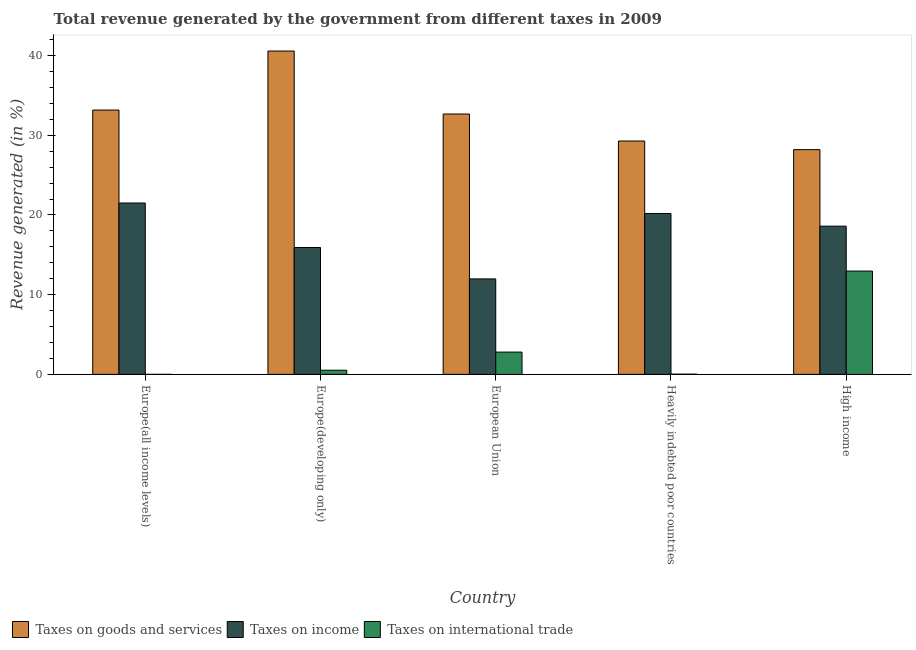Are the number of bars on each tick of the X-axis equal?
Offer a terse response. Yes. What is the percentage of revenue generated by taxes on income in High income?
Your answer should be compact. 18.6. Across all countries, what is the maximum percentage of revenue generated by taxes on goods and services?
Provide a short and direct response. 40.57. Across all countries, what is the minimum percentage of revenue generated by tax on international trade?
Keep it short and to the point. 0. In which country was the percentage of revenue generated by taxes on income maximum?
Offer a very short reply. Europe(all income levels). In which country was the percentage of revenue generated by taxes on goods and services minimum?
Make the answer very short. High income. What is the total percentage of revenue generated by tax on international trade in the graph?
Your answer should be very brief. 16.31. What is the difference between the percentage of revenue generated by taxes on goods and services in Europe(all income levels) and that in Europe(developing only)?
Ensure brevity in your answer.  -7.41. What is the difference between the percentage of revenue generated by tax on international trade in High income and the percentage of revenue generated by taxes on goods and services in Europe(developing only)?
Your answer should be very brief. -27.61. What is the average percentage of revenue generated by taxes on income per country?
Ensure brevity in your answer.  17.64. What is the difference between the percentage of revenue generated by tax on international trade and percentage of revenue generated by taxes on income in Europe(developing only)?
Your answer should be very brief. -15.4. In how many countries, is the percentage of revenue generated by tax on international trade greater than 22 %?
Give a very brief answer. 0. What is the ratio of the percentage of revenue generated by taxes on income in Europe(all income levels) to that in European Union?
Keep it short and to the point. 1.79. Is the percentage of revenue generated by tax on international trade in Europe(developing only) less than that in High income?
Your answer should be very brief. Yes. Is the difference between the percentage of revenue generated by taxes on goods and services in Europe(all income levels) and High income greater than the difference between the percentage of revenue generated by tax on international trade in Europe(all income levels) and High income?
Your answer should be compact. Yes. What is the difference between the highest and the second highest percentage of revenue generated by taxes on goods and services?
Your answer should be very brief. 7.41. What is the difference between the highest and the lowest percentage of revenue generated by taxes on goods and services?
Provide a short and direct response. 12.37. Is the sum of the percentage of revenue generated by tax on international trade in Europe(developing only) and High income greater than the maximum percentage of revenue generated by taxes on income across all countries?
Give a very brief answer. No. What does the 3rd bar from the left in Europe(all income levels) represents?
Offer a terse response. Taxes on international trade. What does the 3rd bar from the right in Europe(all income levels) represents?
Offer a terse response. Taxes on goods and services. How many bars are there?
Provide a succinct answer. 15. Are all the bars in the graph horizontal?
Keep it short and to the point. No. Does the graph contain any zero values?
Provide a short and direct response. No. Does the graph contain grids?
Keep it short and to the point. No. How are the legend labels stacked?
Make the answer very short. Horizontal. What is the title of the graph?
Your answer should be very brief. Total revenue generated by the government from different taxes in 2009. Does "Social Protection and Labor" appear as one of the legend labels in the graph?
Your response must be concise. No. What is the label or title of the X-axis?
Give a very brief answer. Country. What is the label or title of the Y-axis?
Keep it short and to the point. Revenue generated (in %). What is the Revenue generated (in %) in Taxes on goods and services in Europe(all income levels)?
Your response must be concise. 33.17. What is the Revenue generated (in %) in Taxes on income in Europe(all income levels)?
Make the answer very short. 21.5. What is the Revenue generated (in %) of Taxes on international trade in Europe(all income levels)?
Your answer should be very brief. 0. What is the Revenue generated (in %) in Taxes on goods and services in Europe(developing only)?
Provide a succinct answer. 40.57. What is the Revenue generated (in %) of Taxes on income in Europe(developing only)?
Give a very brief answer. 15.92. What is the Revenue generated (in %) in Taxes on international trade in Europe(developing only)?
Give a very brief answer. 0.52. What is the Revenue generated (in %) of Taxes on goods and services in European Union?
Give a very brief answer. 32.67. What is the Revenue generated (in %) of Taxes on income in European Union?
Give a very brief answer. 11.98. What is the Revenue generated (in %) in Taxes on international trade in European Union?
Your answer should be compact. 2.8. What is the Revenue generated (in %) in Taxes on goods and services in Heavily indebted poor countries?
Ensure brevity in your answer.  29.28. What is the Revenue generated (in %) in Taxes on income in Heavily indebted poor countries?
Your answer should be very brief. 20.19. What is the Revenue generated (in %) of Taxes on international trade in Heavily indebted poor countries?
Your answer should be very brief. 0.02. What is the Revenue generated (in %) in Taxes on goods and services in High income?
Your response must be concise. 28.2. What is the Revenue generated (in %) of Taxes on income in High income?
Offer a very short reply. 18.6. What is the Revenue generated (in %) in Taxes on international trade in High income?
Provide a succinct answer. 12.96. Across all countries, what is the maximum Revenue generated (in %) in Taxes on goods and services?
Your answer should be compact. 40.57. Across all countries, what is the maximum Revenue generated (in %) in Taxes on income?
Your response must be concise. 21.5. Across all countries, what is the maximum Revenue generated (in %) in Taxes on international trade?
Give a very brief answer. 12.96. Across all countries, what is the minimum Revenue generated (in %) in Taxes on goods and services?
Offer a terse response. 28.2. Across all countries, what is the minimum Revenue generated (in %) of Taxes on income?
Your answer should be compact. 11.98. Across all countries, what is the minimum Revenue generated (in %) in Taxes on international trade?
Provide a succinct answer. 0. What is the total Revenue generated (in %) in Taxes on goods and services in the graph?
Provide a short and direct response. 163.89. What is the total Revenue generated (in %) of Taxes on income in the graph?
Your answer should be very brief. 88.19. What is the total Revenue generated (in %) of Taxes on international trade in the graph?
Provide a short and direct response. 16.31. What is the difference between the Revenue generated (in %) of Taxes on goods and services in Europe(all income levels) and that in Europe(developing only)?
Offer a terse response. -7.41. What is the difference between the Revenue generated (in %) in Taxes on income in Europe(all income levels) and that in Europe(developing only)?
Provide a succinct answer. 5.58. What is the difference between the Revenue generated (in %) in Taxes on international trade in Europe(all income levels) and that in Europe(developing only)?
Offer a very short reply. -0.52. What is the difference between the Revenue generated (in %) of Taxes on goods and services in Europe(all income levels) and that in European Union?
Give a very brief answer. 0.5. What is the difference between the Revenue generated (in %) in Taxes on income in Europe(all income levels) and that in European Union?
Your response must be concise. 9.52. What is the difference between the Revenue generated (in %) of Taxes on international trade in Europe(all income levels) and that in European Union?
Give a very brief answer. -2.79. What is the difference between the Revenue generated (in %) of Taxes on goods and services in Europe(all income levels) and that in Heavily indebted poor countries?
Offer a very short reply. 3.89. What is the difference between the Revenue generated (in %) in Taxes on income in Europe(all income levels) and that in Heavily indebted poor countries?
Ensure brevity in your answer.  1.31. What is the difference between the Revenue generated (in %) in Taxes on international trade in Europe(all income levels) and that in Heavily indebted poor countries?
Provide a short and direct response. -0.02. What is the difference between the Revenue generated (in %) of Taxes on goods and services in Europe(all income levels) and that in High income?
Offer a terse response. 4.97. What is the difference between the Revenue generated (in %) of Taxes on income in Europe(all income levels) and that in High income?
Offer a terse response. 2.9. What is the difference between the Revenue generated (in %) of Taxes on international trade in Europe(all income levels) and that in High income?
Offer a terse response. -12.96. What is the difference between the Revenue generated (in %) in Taxes on goods and services in Europe(developing only) and that in European Union?
Give a very brief answer. 7.9. What is the difference between the Revenue generated (in %) of Taxes on income in Europe(developing only) and that in European Union?
Your answer should be compact. 3.94. What is the difference between the Revenue generated (in %) of Taxes on international trade in Europe(developing only) and that in European Union?
Your response must be concise. -2.27. What is the difference between the Revenue generated (in %) in Taxes on goods and services in Europe(developing only) and that in Heavily indebted poor countries?
Your response must be concise. 11.29. What is the difference between the Revenue generated (in %) of Taxes on income in Europe(developing only) and that in Heavily indebted poor countries?
Your answer should be compact. -4.27. What is the difference between the Revenue generated (in %) of Taxes on international trade in Europe(developing only) and that in Heavily indebted poor countries?
Make the answer very short. 0.5. What is the difference between the Revenue generated (in %) in Taxes on goods and services in Europe(developing only) and that in High income?
Offer a terse response. 12.37. What is the difference between the Revenue generated (in %) of Taxes on income in Europe(developing only) and that in High income?
Provide a succinct answer. -2.68. What is the difference between the Revenue generated (in %) of Taxes on international trade in Europe(developing only) and that in High income?
Your answer should be compact. -12.44. What is the difference between the Revenue generated (in %) of Taxes on goods and services in European Union and that in Heavily indebted poor countries?
Your answer should be very brief. 3.39. What is the difference between the Revenue generated (in %) in Taxes on income in European Union and that in Heavily indebted poor countries?
Your response must be concise. -8.21. What is the difference between the Revenue generated (in %) of Taxes on international trade in European Union and that in Heavily indebted poor countries?
Give a very brief answer. 2.77. What is the difference between the Revenue generated (in %) of Taxes on goods and services in European Union and that in High income?
Make the answer very short. 4.47. What is the difference between the Revenue generated (in %) of Taxes on income in European Union and that in High income?
Your response must be concise. -6.62. What is the difference between the Revenue generated (in %) in Taxes on international trade in European Union and that in High income?
Offer a terse response. -10.17. What is the difference between the Revenue generated (in %) of Taxes on goods and services in Heavily indebted poor countries and that in High income?
Make the answer very short. 1.08. What is the difference between the Revenue generated (in %) of Taxes on income in Heavily indebted poor countries and that in High income?
Ensure brevity in your answer.  1.59. What is the difference between the Revenue generated (in %) of Taxes on international trade in Heavily indebted poor countries and that in High income?
Provide a short and direct response. -12.94. What is the difference between the Revenue generated (in %) in Taxes on goods and services in Europe(all income levels) and the Revenue generated (in %) in Taxes on income in Europe(developing only)?
Make the answer very short. 17.25. What is the difference between the Revenue generated (in %) in Taxes on goods and services in Europe(all income levels) and the Revenue generated (in %) in Taxes on international trade in Europe(developing only)?
Offer a very short reply. 32.64. What is the difference between the Revenue generated (in %) in Taxes on income in Europe(all income levels) and the Revenue generated (in %) in Taxes on international trade in Europe(developing only)?
Keep it short and to the point. 20.98. What is the difference between the Revenue generated (in %) of Taxes on goods and services in Europe(all income levels) and the Revenue generated (in %) of Taxes on income in European Union?
Your answer should be compact. 21.19. What is the difference between the Revenue generated (in %) of Taxes on goods and services in Europe(all income levels) and the Revenue generated (in %) of Taxes on international trade in European Union?
Provide a succinct answer. 30.37. What is the difference between the Revenue generated (in %) in Taxes on income in Europe(all income levels) and the Revenue generated (in %) in Taxes on international trade in European Union?
Make the answer very short. 18.71. What is the difference between the Revenue generated (in %) in Taxes on goods and services in Europe(all income levels) and the Revenue generated (in %) in Taxes on income in Heavily indebted poor countries?
Offer a terse response. 12.98. What is the difference between the Revenue generated (in %) in Taxes on goods and services in Europe(all income levels) and the Revenue generated (in %) in Taxes on international trade in Heavily indebted poor countries?
Offer a very short reply. 33.14. What is the difference between the Revenue generated (in %) in Taxes on income in Europe(all income levels) and the Revenue generated (in %) in Taxes on international trade in Heavily indebted poor countries?
Provide a short and direct response. 21.48. What is the difference between the Revenue generated (in %) in Taxes on goods and services in Europe(all income levels) and the Revenue generated (in %) in Taxes on income in High income?
Provide a succinct answer. 14.57. What is the difference between the Revenue generated (in %) of Taxes on goods and services in Europe(all income levels) and the Revenue generated (in %) of Taxes on international trade in High income?
Provide a short and direct response. 20.2. What is the difference between the Revenue generated (in %) of Taxes on income in Europe(all income levels) and the Revenue generated (in %) of Taxes on international trade in High income?
Offer a very short reply. 8.54. What is the difference between the Revenue generated (in %) of Taxes on goods and services in Europe(developing only) and the Revenue generated (in %) of Taxes on income in European Union?
Your response must be concise. 28.59. What is the difference between the Revenue generated (in %) in Taxes on goods and services in Europe(developing only) and the Revenue generated (in %) in Taxes on international trade in European Union?
Provide a succinct answer. 37.78. What is the difference between the Revenue generated (in %) of Taxes on income in Europe(developing only) and the Revenue generated (in %) of Taxes on international trade in European Union?
Keep it short and to the point. 13.12. What is the difference between the Revenue generated (in %) in Taxes on goods and services in Europe(developing only) and the Revenue generated (in %) in Taxes on income in Heavily indebted poor countries?
Your answer should be very brief. 20.38. What is the difference between the Revenue generated (in %) in Taxes on goods and services in Europe(developing only) and the Revenue generated (in %) in Taxes on international trade in Heavily indebted poor countries?
Offer a very short reply. 40.55. What is the difference between the Revenue generated (in %) of Taxes on income in Europe(developing only) and the Revenue generated (in %) of Taxes on international trade in Heavily indebted poor countries?
Offer a very short reply. 15.9. What is the difference between the Revenue generated (in %) of Taxes on goods and services in Europe(developing only) and the Revenue generated (in %) of Taxes on income in High income?
Your response must be concise. 21.97. What is the difference between the Revenue generated (in %) in Taxes on goods and services in Europe(developing only) and the Revenue generated (in %) in Taxes on international trade in High income?
Offer a very short reply. 27.61. What is the difference between the Revenue generated (in %) in Taxes on income in Europe(developing only) and the Revenue generated (in %) in Taxes on international trade in High income?
Your answer should be very brief. 2.96. What is the difference between the Revenue generated (in %) in Taxes on goods and services in European Union and the Revenue generated (in %) in Taxes on income in Heavily indebted poor countries?
Provide a short and direct response. 12.48. What is the difference between the Revenue generated (in %) of Taxes on goods and services in European Union and the Revenue generated (in %) of Taxes on international trade in Heavily indebted poor countries?
Make the answer very short. 32.65. What is the difference between the Revenue generated (in %) of Taxes on income in European Union and the Revenue generated (in %) of Taxes on international trade in Heavily indebted poor countries?
Your response must be concise. 11.96. What is the difference between the Revenue generated (in %) in Taxes on goods and services in European Union and the Revenue generated (in %) in Taxes on income in High income?
Provide a short and direct response. 14.07. What is the difference between the Revenue generated (in %) of Taxes on goods and services in European Union and the Revenue generated (in %) of Taxes on international trade in High income?
Your response must be concise. 19.71. What is the difference between the Revenue generated (in %) of Taxes on income in European Union and the Revenue generated (in %) of Taxes on international trade in High income?
Your answer should be very brief. -0.98. What is the difference between the Revenue generated (in %) in Taxes on goods and services in Heavily indebted poor countries and the Revenue generated (in %) in Taxes on income in High income?
Your answer should be very brief. 10.68. What is the difference between the Revenue generated (in %) of Taxes on goods and services in Heavily indebted poor countries and the Revenue generated (in %) of Taxes on international trade in High income?
Make the answer very short. 16.32. What is the difference between the Revenue generated (in %) of Taxes on income in Heavily indebted poor countries and the Revenue generated (in %) of Taxes on international trade in High income?
Offer a terse response. 7.23. What is the average Revenue generated (in %) in Taxes on goods and services per country?
Your answer should be very brief. 32.78. What is the average Revenue generated (in %) of Taxes on income per country?
Keep it short and to the point. 17.64. What is the average Revenue generated (in %) of Taxes on international trade per country?
Keep it short and to the point. 3.26. What is the difference between the Revenue generated (in %) of Taxes on goods and services and Revenue generated (in %) of Taxes on income in Europe(all income levels)?
Make the answer very short. 11.66. What is the difference between the Revenue generated (in %) in Taxes on goods and services and Revenue generated (in %) in Taxes on international trade in Europe(all income levels)?
Offer a terse response. 33.17. What is the difference between the Revenue generated (in %) of Taxes on income and Revenue generated (in %) of Taxes on international trade in Europe(all income levels)?
Your answer should be very brief. 21.5. What is the difference between the Revenue generated (in %) in Taxes on goods and services and Revenue generated (in %) in Taxes on income in Europe(developing only)?
Your response must be concise. 24.65. What is the difference between the Revenue generated (in %) in Taxes on goods and services and Revenue generated (in %) in Taxes on international trade in Europe(developing only)?
Your response must be concise. 40.05. What is the difference between the Revenue generated (in %) in Taxes on income and Revenue generated (in %) in Taxes on international trade in Europe(developing only)?
Offer a very short reply. 15.4. What is the difference between the Revenue generated (in %) of Taxes on goods and services and Revenue generated (in %) of Taxes on income in European Union?
Your answer should be very brief. 20.69. What is the difference between the Revenue generated (in %) of Taxes on goods and services and Revenue generated (in %) of Taxes on international trade in European Union?
Your answer should be very brief. 29.87. What is the difference between the Revenue generated (in %) in Taxes on income and Revenue generated (in %) in Taxes on international trade in European Union?
Offer a very short reply. 9.19. What is the difference between the Revenue generated (in %) of Taxes on goods and services and Revenue generated (in %) of Taxes on income in Heavily indebted poor countries?
Your answer should be compact. 9.09. What is the difference between the Revenue generated (in %) of Taxes on goods and services and Revenue generated (in %) of Taxes on international trade in Heavily indebted poor countries?
Give a very brief answer. 29.26. What is the difference between the Revenue generated (in %) in Taxes on income and Revenue generated (in %) in Taxes on international trade in Heavily indebted poor countries?
Provide a short and direct response. 20.17. What is the difference between the Revenue generated (in %) of Taxes on goods and services and Revenue generated (in %) of Taxes on income in High income?
Give a very brief answer. 9.6. What is the difference between the Revenue generated (in %) in Taxes on goods and services and Revenue generated (in %) in Taxes on international trade in High income?
Ensure brevity in your answer.  15.24. What is the difference between the Revenue generated (in %) in Taxes on income and Revenue generated (in %) in Taxes on international trade in High income?
Give a very brief answer. 5.64. What is the ratio of the Revenue generated (in %) in Taxes on goods and services in Europe(all income levels) to that in Europe(developing only)?
Keep it short and to the point. 0.82. What is the ratio of the Revenue generated (in %) in Taxes on income in Europe(all income levels) to that in Europe(developing only)?
Your response must be concise. 1.35. What is the ratio of the Revenue generated (in %) of Taxes on international trade in Europe(all income levels) to that in Europe(developing only)?
Your response must be concise. 0. What is the ratio of the Revenue generated (in %) in Taxes on goods and services in Europe(all income levels) to that in European Union?
Offer a terse response. 1.02. What is the ratio of the Revenue generated (in %) in Taxes on income in Europe(all income levels) to that in European Union?
Ensure brevity in your answer.  1.79. What is the ratio of the Revenue generated (in %) of Taxes on international trade in Europe(all income levels) to that in European Union?
Provide a short and direct response. 0. What is the ratio of the Revenue generated (in %) of Taxes on goods and services in Europe(all income levels) to that in Heavily indebted poor countries?
Give a very brief answer. 1.13. What is the ratio of the Revenue generated (in %) in Taxes on income in Europe(all income levels) to that in Heavily indebted poor countries?
Keep it short and to the point. 1.06. What is the ratio of the Revenue generated (in %) in Taxes on international trade in Europe(all income levels) to that in Heavily indebted poor countries?
Provide a short and direct response. 0.07. What is the ratio of the Revenue generated (in %) of Taxes on goods and services in Europe(all income levels) to that in High income?
Provide a succinct answer. 1.18. What is the ratio of the Revenue generated (in %) of Taxes on income in Europe(all income levels) to that in High income?
Make the answer very short. 1.16. What is the ratio of the Revenue generated (in %) in Taxes on international trade in Europe(all income levels) to that in High income?
Offer a very short reply. 0. What is the ratio of the Revenue generated (in %) of Taxes on goods and services in Europe(developing only) to that in European Union?
Your answer should be very brief. 1.24. What is the ratio of the Revenue generated (in %) in Taxes on income in Europe(developing only) to that in European Union?
Give a very brief answer. 1.33. What is the ratio of the Revenue generated (in %) in Taxes on international trade in Europe(developing only) to that in European Union?
Make the answer very short. 0.19. What is the ratio of the Revenue generated (in %) in Taxes on goods and services in Europe(developing only) to that in Heavily indebted poor countries?
Offer a very short reply. 1.39. What is the ratio of the Revenue generated (in %) in Taxes on income in Europe(developing only) to that in Heavily indebted poor countries?
Provide a short and direct response. 0.79. What is the ratio of the Revenue generated (in %) of Taxes on international trade in Europe(developing only) to that in Heavily indebted poor countries?
Your answer should be compact. 22.49. What is the ratio of the Revenue generated (in %) in Taxes on goods and services in Europe(developing only) to that in High income?
Offer a terse response. 1.44. What is the ratio of the Revenue generated (in %) of Taxes on income in Europe(developing only) to that in High income?
Make the answer very short. 0.86. What is the ratio of the Revenue generated (in %) in Taxes on international trade in Europe(developing only) to that in High income?
Your answer should be very brief. 0.04. What is the ratio of the Revenue generated (in %) of Taxes on goods and services in European Union to that in Heavily indebted poor countries?
Ensure brevity in your answer.  1.12. What is the ratio of the Revenue generated (in %) of Taxes on income in European Union to that in Heavily indebted poor countries?
Your answer should be compact. 0.59. What is the ratio of the Revenue generated (in %) in Taxes on international trade in European Union to that in Heavily indebted poor countries?
Provide a succinct answer. 120.39. What is the ratio of the Revenue generated (in %) in Taxes on goods and services in European Union to that in High income?
Offer a very short reply. 1.16. What is the ratio of the Revenue generated (in %) in Taxes on income in European Union to that in High income?
Your answer should be very brief. 0.64. What is the ratio of the Revenue generated (in %) in Taxes on international trade in European Union to that in High income?
Provide a succinct answer. 0.22. What is the ratio of the Revenue generated (in %) in Taxes on goods and services in Heavily indebted poor countries to that in High income?
Your answer should be compact. 1.04. What is the ratio of the Revenue generated (in %) of Taxes on income in Heavily indebted poor countries to that in High income?
Ensure brevity in your answer.  1.09. What is the ratio of the Revenue generated (in %) of Taxes on international trade in Heavily indebted poor countries to that in High income?
Give a very brief answer. 0. What is the difference between the highest and the second highest Revenue generated (in %) in Taxes on goods and services?
Provide a short and direct response. 7.41. What is the difference between the highest and the second highest Revenue generated (in %) in Taxes on income?
Offer a terse response. 1.31. What is the difference between the highest and the second highest Revenue generated (in %) of Taxes on international trade?
Offer a very short reply. 10.17. What is the difference between the highest and the lowest Revenue generated (in %) of Taxes on goods and services?
Your response must be concise. 12.37. What is the difference between the highest and the lowest Revenue generated (in %) in Taxes on income?
Provide a short and direct response. 9.52. What is the difference between the highest and the lowest Revenue generated (in %) in Taxes on international trade?
Offer a terse response. 12.96. 